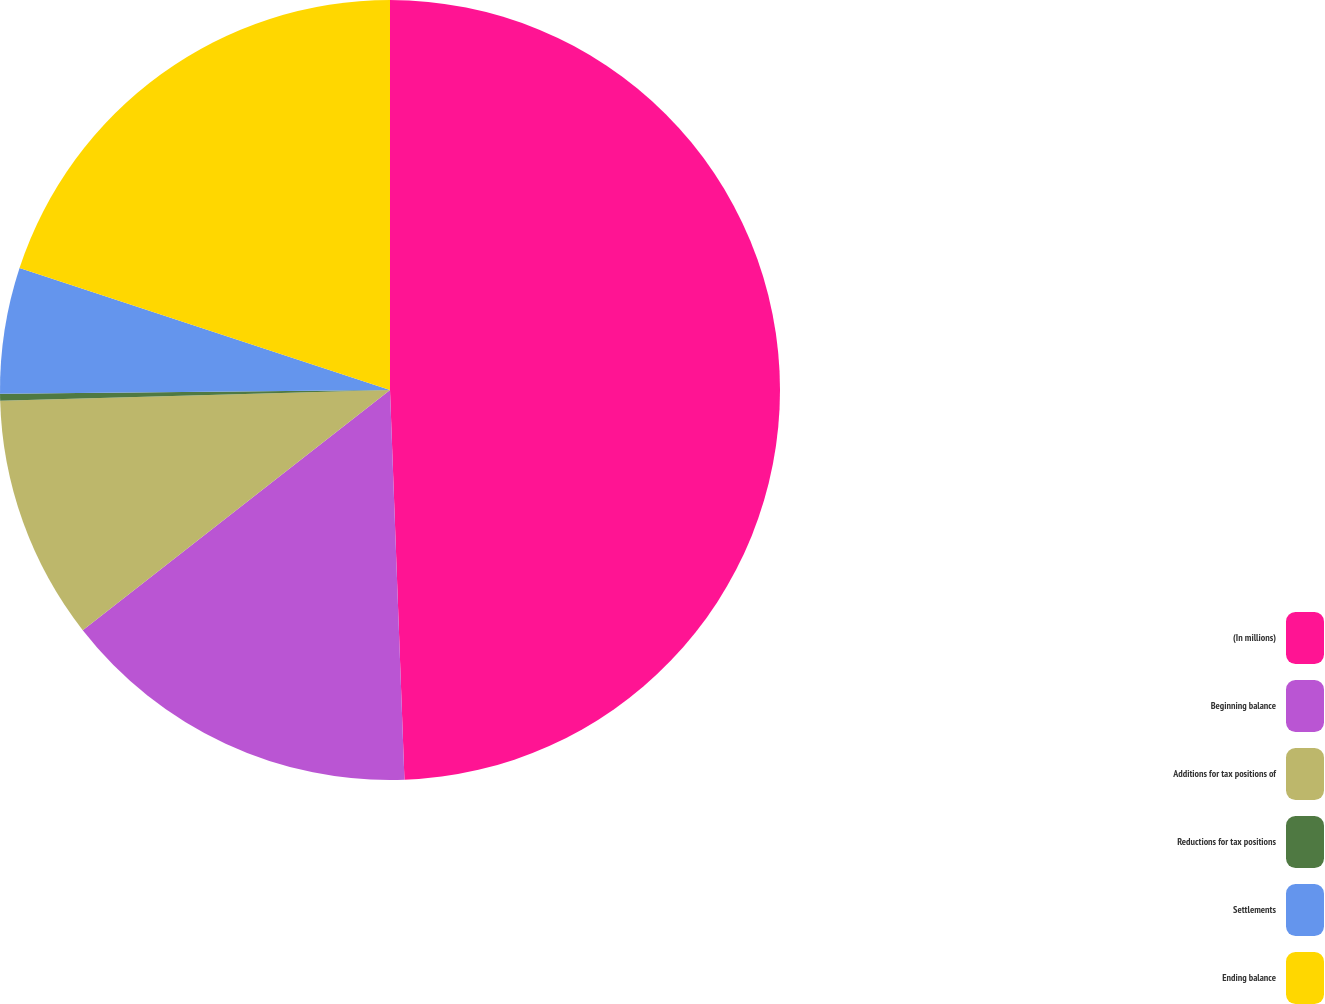Convert chart to OTSL. <chart><loc_0><loc_0><loc_500><loc_500><pie_chart><fcel>(In millions)<fcel>Beginning balance<fcel>Additions for tax positions of<fcel>Reductions for tax positions<fcel>Settlements<fcel>Ending balance<nl><fcel>49.41%<fcel>15.03%<fcel>10.12%<fcel>0.29%<fcel>5.21%<fcel>19.94%<nl></chart> 